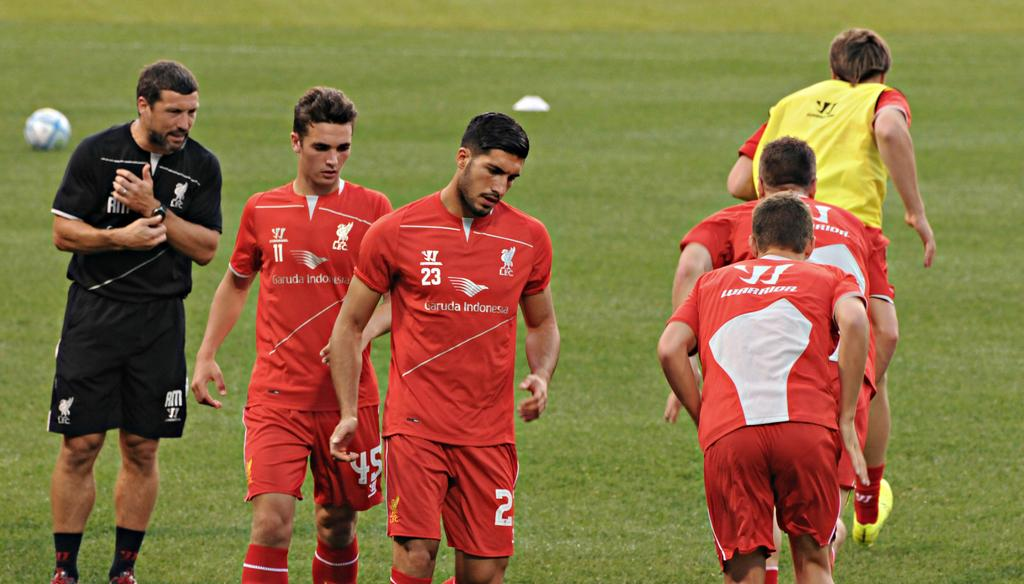What is the main subject of the image? The main subject of the image is the persons in the center. What can be seen in the background of the image? There is a ball and a ground visible in the background of the image. How many babies are crawling on the ground in the image? There is no mention of babies in the image; the main subjects are the persons in the center, and the background elements include a ball and a ground. 